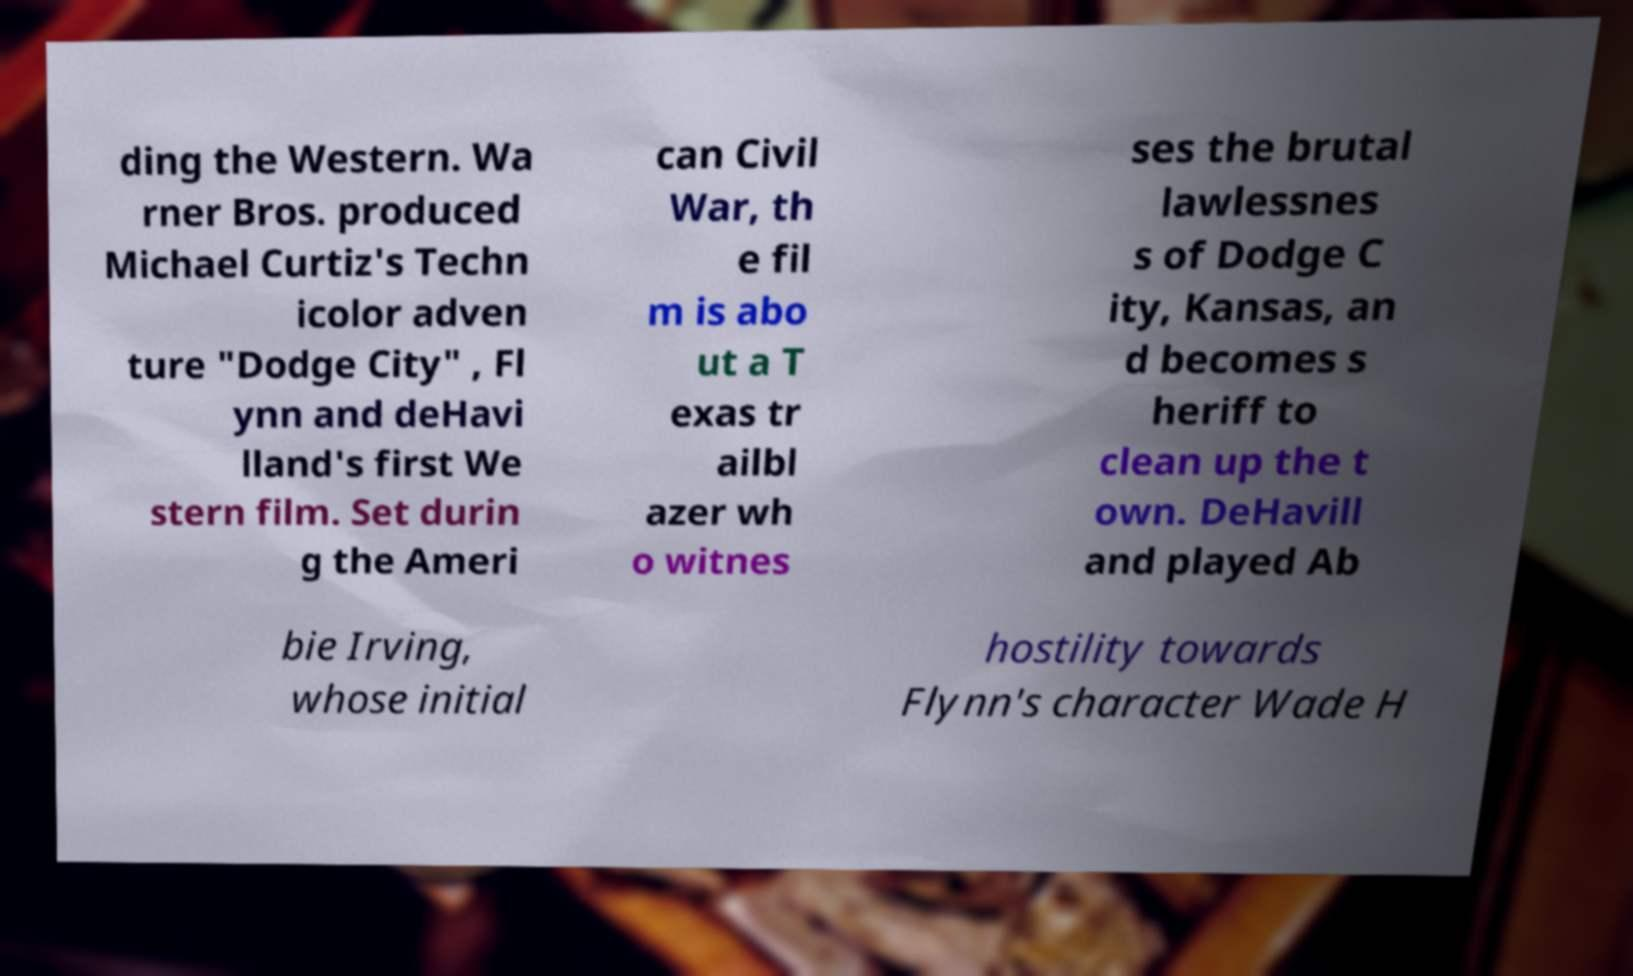Could you extract and type out the text from this image? ding the Western. Wa rner Bros. produced Michael Curtiz's Techn icolor adven ture "Dodge City" , Fl ynn and deHavi lland's first We stern film. Set durin g the Ameri can Civil War, th e fil m is abo ut a T exas tr ailbl azer wh o witnes ses the brutal lawlessnes s of Dodge C ity, Kansas, an d becomes s heriff to clean up the t own. DeHavill and played Ab bie Irving, whose initial hostility towards Flynn's character Wade H 